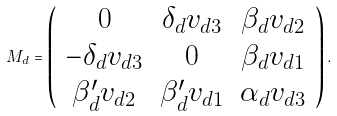<formula> <loc_0><loc_0><loc_500><loc_500>M _ { d } = \left ( \begin{array} { c c c } 0 & \delta _ { d } v _ { d 3 } & \beta _ { d } v _ { d 2 } \\ - \delta _ { d } v _ { d 3 } & 0 & \beta _ { d } v _ { d 1 } \\ \beta ^ { \prime } _ { d } v _ { d 2 } & \beta ^ { \prime } _ { d } v _ { d 1 } & \alpha _ { d } v _ { d 3 } \end{array} \right ) .</formula> 